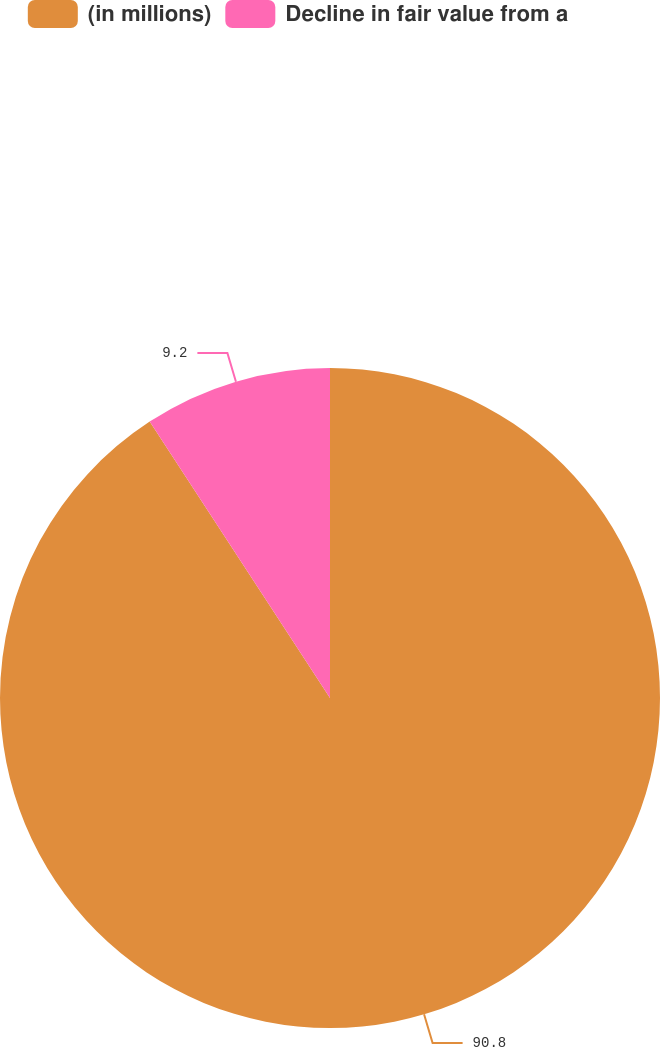Convert chart. <chart><loc_0><loc_0><loc_500><loc_500><pie_chart><fcel>(in millions)<fcel>Decline in fair value from a<nl><fcel>90.8%<fcel>9.2%<nl></chart> 